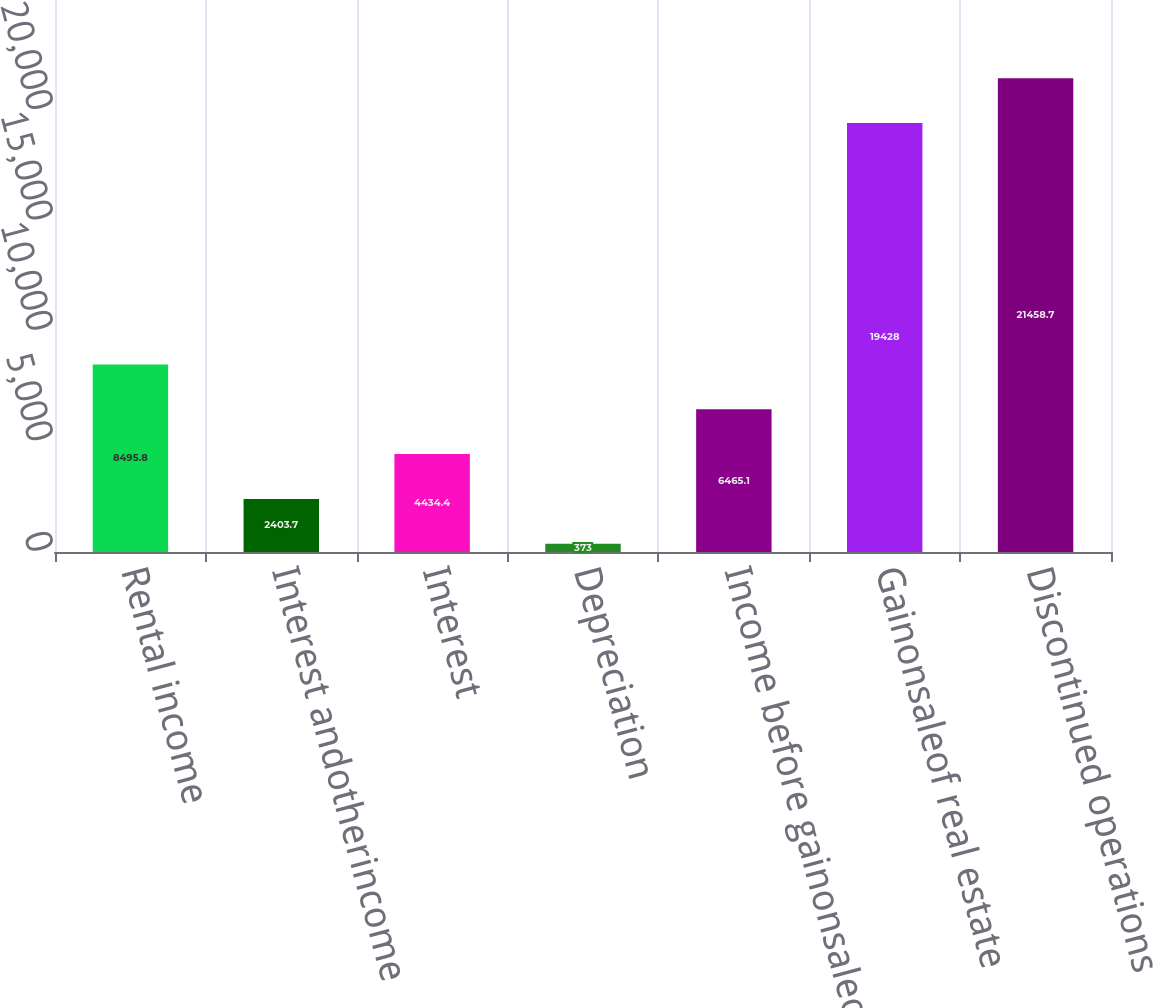Convert chart to OTSL. <chart><loc_0><loc_0><loc_500><loc_500><bar_chart><fcel>Rental income<fcel>Interest andotherincome<fcel>Interest<fcel>Depreciation<fcel>Income before gainonsaleof<fcel>Gainonsaleof real estate<fcel>Discontinued operations<nl><fcel>8495.8<fcel>2403.7<fcel>4434.4<fcel>373<fcel>6465.1<fcel>19428<fcel>21458.7<nl></chart> 